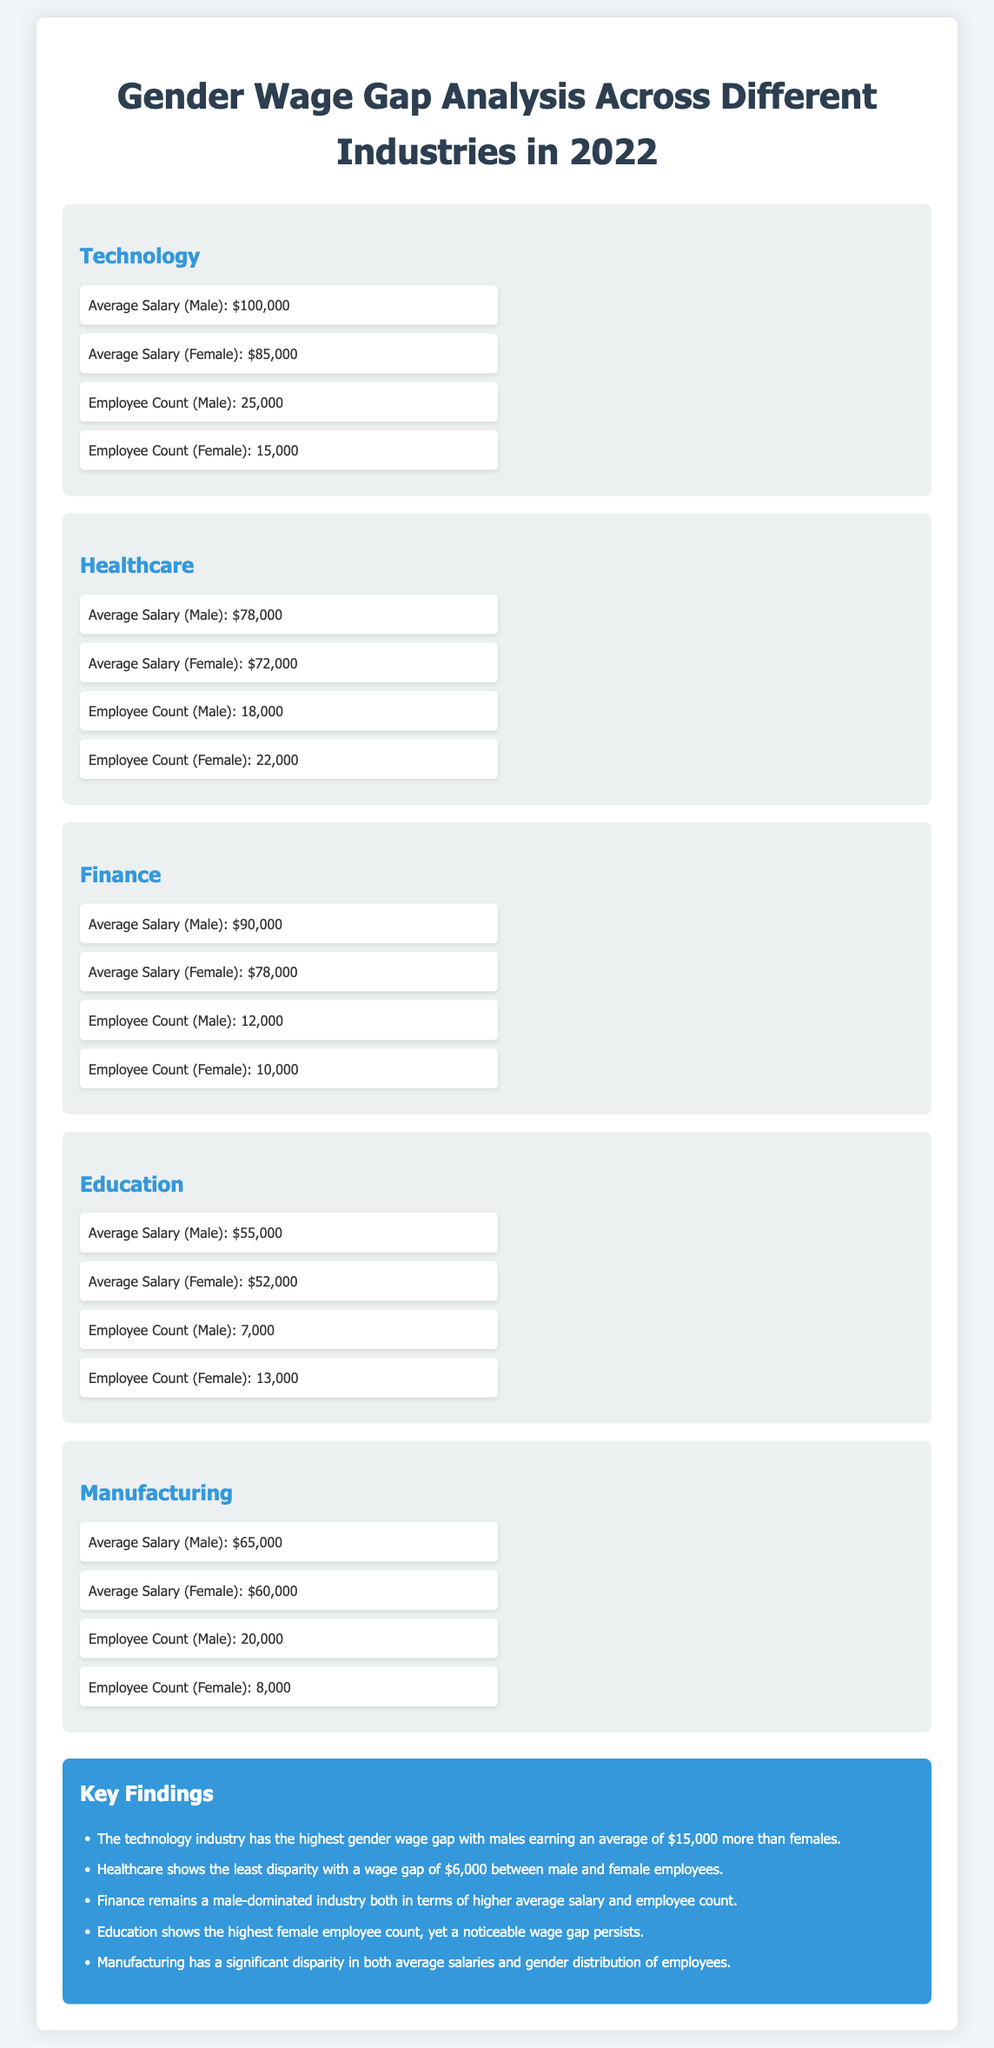What is the average salary for males in the Technology industry? The average salary for males in the Technology industry is explicitly stated in the document.
Answer: $100,000 What is the employee count for females in the Healthcare industry? The document provides the employee count for females in the Healthcare industry specifically.
Answer: 22,000 What is the gender wage gap in the Finance industry? The wage gap is calculated based on the difference between the average salaries of males and females in the Finance industry mentioned in the document.
Answer: $12,000 Which industry has the highest average salary for females? By comparing the average salaries for females across all industries, we can identify which has the highest.
Answer: Technology How many males are employed in Manufacturing? The document gives the specific count of male employees in the Manufacturing industry.
Answer: 20,000 What is the summary finding regarding the disparity in the Healthcare industry? The summary section of the document notes the wage gap disparity in the Healthcare industry.
Answer: Least disparity How many industries show a wage gap greater than $10,000? To find the answer, one has to assess the wage gaps for each industry presented in the document.
Answer: 3 Which industry has the highest female employee count? The answer is based on a comparison of employee counts among genders across the industries in the document.
Answer: Education What is the average salary for females in the Manufacturing industry? The document provides the average salary for females in the Manufacturing sector directly.
Answer: $60,000 